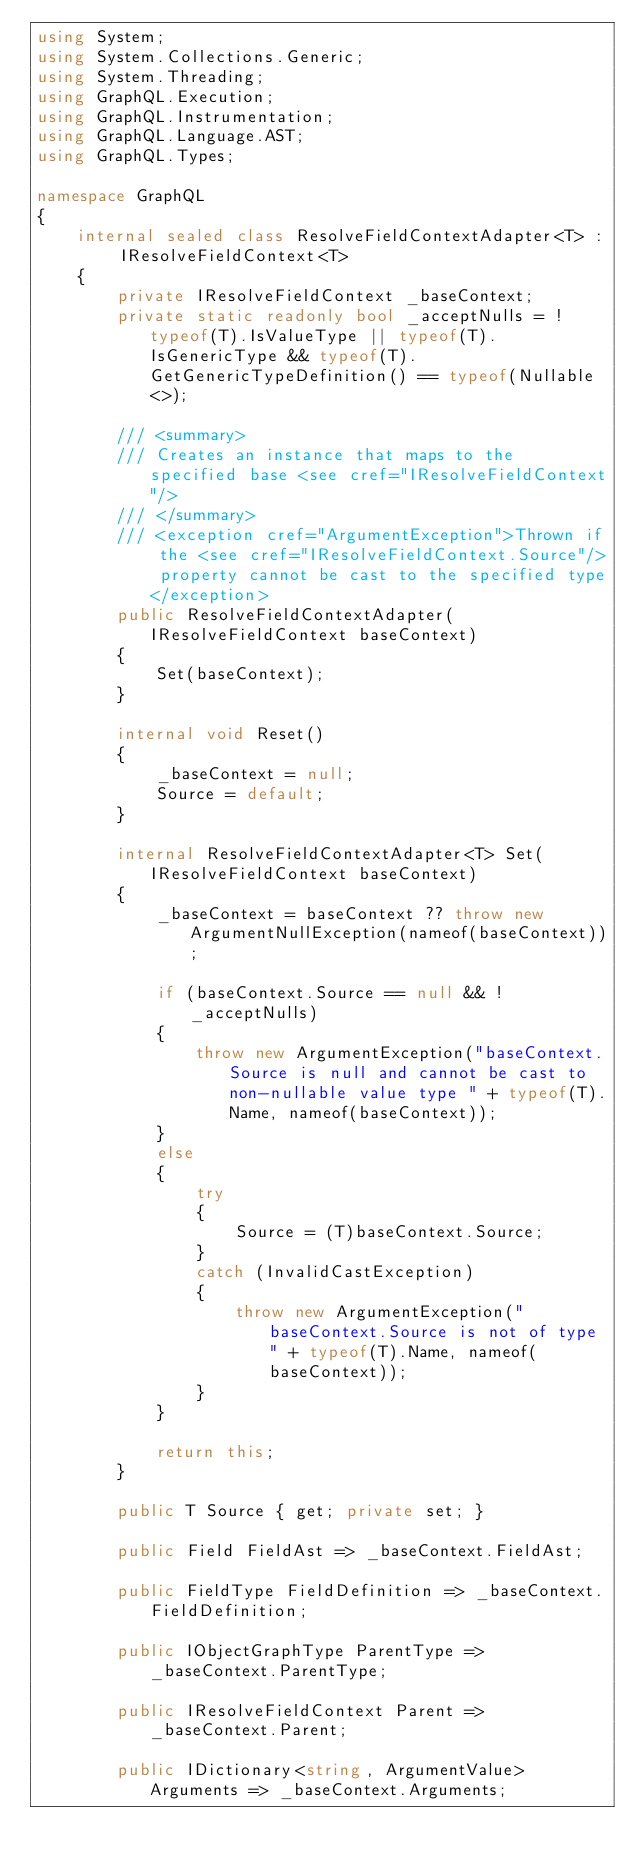<code> <loc_0><loc_0><loc_500><loc_500><_C#_>using System;
using System.Collections.Generic;
using System.Threading;
using GraphQL.Execution;
using GraphQL.Instrumentation;
using GraphQL.Language.AST;
using GraphQL.Types;

namespace GraphQL
{
    internal sealed class ResolveFieldContextAdapter<T> : IResolveFieldContext<T>
    {
        private IResolveFieldContext _baseContext;
        private static readonly bool _acceptNulls = !typeof(T).IsValueType || typeof(T).IsGenericType && typeof(T).GetGenericTypeDefinition() == typeof(Nullable<>);

        /// <summary>
        /// Creates an instance that maps to the specified base <see cref="IResolveFieldContext"/>
        /// </summary>
        /// <exception cref="ArgumentException">Thrown if the <see cref="IResolveFieldContext.Source"/> property cannot be cast to the specified type</exception>
        public ResolveFieldContextAdapter(IResolveFieldContext baseContext)
        {
            Set(baseContext);
        }

        internal void Reset()
        {
            _baseContext = null;
            Source = default;
        }

        internal ResolveFieldContextAdapter<T> Set(IResolveFieldContext baseContext)
        {
            _baseContext = baseContext ?? throw new ArgumentNullException(nameof(baseContext));

            if (baseContext.Source == null && !_acceptNulls)
            {
                throw new ArgumentException("baseContext.Source is null and cannot be cast to non-nullable value type " + typeof(T).Name, nameof(baseContext));
            }
            else
            {
                try
                {
                    Source = (T)baseContext.Source;
                }
                catch (InvalidCastException)
                {
                    throw new ArgumentException("baseContext.Source is not of type " + typeof(T).Name, nameof(baseContext));
                }
            }

            return this;
        }

        public T Source { get; private set; }

        public Field FieldAst => _baseContext.FieldAst;

        public FieldType FieldDefinition => _baseContext.FieldDefinition;

        public IObjectGraphType ParentType => _baseContext.ParentType;

        public IResolveFieldContext Parent => _baseContext.Parent;

        public IDictionary<string, ArgumentValue> Arguments => _baseContext.Arguments;
</code> 